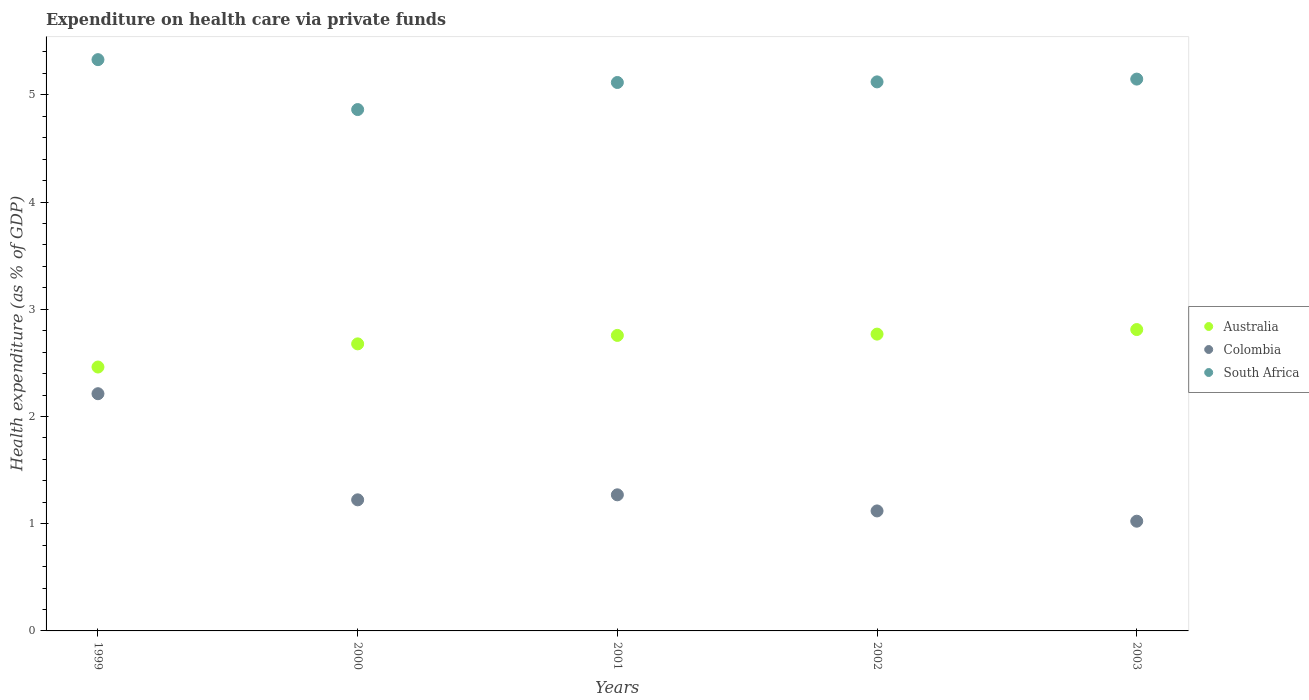What is the expenditure made on health care in Colombia in 2002?
Provide a succinct answer. 1.12. Across all years, what is the maximum expenditure made on health care in Australia?
Give a very brief answer. 2.81. Across all years, what is the minimum expenditure made on health care in Colombia?
Make the answer very short. 1.02. In which year was the expenditure made on health care in Australia maximum?
Make the answer very short. 2003. What is the total expenditure made on health care in Australia in the graph?
Ensure brevity in your answer.  13.47. What is the difference between the expenditure made on health care in Colombia in 2001 and that in 2003?
Offer a terse response. 0.25. What is the difference between the expenditure made on health care in Australia in 2002 and the expenditure made on health care in Colombia in 1999?
Make the answer very short. 0.56. What is the average expenditure made on health care in South Africa per year?
Offer a terse response. 5.12. In the year 2003, what is the difference between the expenditure made on health care in Colombia and expenditure made on health care in Australia?
Your response must be concise. -1.79. In how many years, is the expenditure made on health care in Colombia greater than 2.4 %?
Your answer should be compact. 0. What is the ratio of the expenditure made on health care in Australia in 2002 to that in 2003?
Provide a short and direct response. 0.98. Is the difference between the expenditure made on health care in Colombia in 2001 and 2003 greater than the difference between the expenditure made on health care in Australia in 2001 and 2003?
Keep it short and to the point. Yes. What is the difference between the highest and the second highest expenditure made on health care in Australia?
Provide a succinct answer. 0.04. What is the difference between the highest and the lowest expenditure made on health care in South Africa?
Your response must be concise. 0.47. Is the expenditure made on health care in Australia strictly greater than the expenditure made on health care in South Africa over the years?
Your answer should be very brief. No. Is the expenditure made on health care in Australia strictly less than the expenditure made on health care in South Africa over the years?
Your answer should be compact. Yes. How many years are there in the graph?
Make the answer very short. 5. Are the values on the major ticks of Y-axis written in scientific E-notation?
Make the answer very short. No. Does the graph contain any zero values?
Offer a very short reply. No. How many legend labels are there?
Make the answer very short. 3. What is the title of the graph?
Make the answer very short. Expenditure on health care via private funds. What is the label or title of the Y-axis?
Offer a terse response. Health expenditure (as % of GDP). What is the Health expenditure (as % of GDP) in Australia in 1999?
Ensure brevity in your answer.  2.46. What is the Health expenditure (as % of GDP) in Colombia in 1999?
Your answer should be very brief. 2.21. What is the Health expenditure (as % of GDP) of South Africa in 1999?
Keep it short and to the point. 5.33. What is the Health expenditure (as % of GDP) in Australia in 2000?
Give a very brief answer. 2.68. What is the Health expenditure (as % of GDP) in Colombia in 2000?
Ensure brevity in your answer.  1.22. What is the Health expenditure (as % of GDP) of South Africa in 2000?
Offer a very short reply. 4.86. What is the Health expenditure (as % of GDP) in Australia in 2001?
Provide a succinct answer. 2.76. What is the Health expenditure (as % of GDP) of Colombia in 2001?
Give a very brief answer. 1.27. What is the Health expenditure (as % of GDP) in South Africa in 2001?
Offer a terse response. 5.12. What is the Health expenditure (as % of GDP) in Australia in 2002?
Your answer should be compact. 2.77. What is the Health expenditure (as % of GDP) in Colombia in 2002?
Offer a terse response. 1.12. What is the Health expenditure (as % of GDP) in South Africa in 2002?
Your response must be concise. 5.12. What is the Health expenditure (as % of GDP) in Australia in 2003?
Your answer should be compact. 2.81. What is the Health expenditure (as % of GDP) of Colombia in 2003?
Your answer should be compact. 1.02. What is the Health expenditure (as % of GDP) in South Africa in 2003?
Your response must be concise. 5.15. Across all years, what is the maximum Health expenditure (as % of GDP) of Australia?
Offer a terse response. 2.81. Across all years, what is the maximum Health expenditure (as % of GDP) in Colombia?
Your response must be concise. 2.21. Across all years, what is the maximum Health expenditure (as % of GDP) in South Africa?
Give a very brief answer. 5.33. Across all years, what is the minimum Health expenditure (as % of GDP) of Australia?
Provide a succinct answer. 2.46. Across all years, what is the minimum Health expenditure (as % of GDP) in Colombia?
Your answer should be very brief. 1.02. Across all years, what is the minimum Health expenditure (as % of GDP) of South Africa?
Offer a very short reply. 4.86. What is the total Health expenditure (as % of GDP) of Australia in the graph?
Ensure brevity in your answer.  13.47. What is the total Health expenditure (as % of GDP) of Colombia in the graph?
Provide a succinct answer. 6.85. What is the total Health expenditure (as % of GDP) in South Africa in the graph?
Your response must be concise. 25.58. What is the difference between the Health expenditure (as % of GDP) in Australia in 1999 and that in 2000?
Your answer should be compact. -0.22. What is the difference between the Health expenditure (as % of GDP) of Colombia in 1999 and that in 2000?
Ensure brevity in your answer.  0.99. What is the difference between the Health expenditure (as % of GDP) in South Africa in 1999 and that in 2000?
Give a very brief answer. 0.47. What is the difference between the Health expenditure (as % of GDP) in Australia in 1999 and that in 2001?
Keep it short and to the point. -0.29. What is the difference between the Health expenditure (as % of GDP) in Colombia in 1999 and that in 2001?
Your response must be concise. 0.94. What is the difference between the Health expenditure (as % of GDP) in South Africa in 1999 and that in 2001?
Provide a succinct answer. 0.21. What is the difference between the Health expenditure (as % of GDP) in Australia in 1999 and that in 2002?
Offer a very short reply. -0.31. What is the difference between the Health expenditure (as % of GDP) in Colombia in 1999 and that in 2002?
Ensure brevity in your answer.  1.09. What is the difference between the Health expenditure (as % of GDP) in South Africa in 1999 and that in 2002?
Make the answer very short. 0.21. What is the difference between the Health expenditure (as % of GDP) in Australia in 1999 and that in 2003?
Ensure brevity in your answer.  -0.35. What is the difference between the Health expenditure (as % of GDP) in Colombia in 1999 and that in 2003?
Provide a short and direct response. 1.19. What is the difference between the Health expenditure (as % of GDP) of South Africa in 1999 and that in 2003?
Offer a terse response. 0.18. What is the difference between the Health expenditure (as % of GDP) of Australia in 2000 and that in 2001?
Make the answer very short. -0.08. What is the difference between the Health expenditure (as % of GDP) in Colombia in 2000 and that in 2001?
Make the answer very short. -0.05. What is the difference between the Health expenditure (as % of GDP) in South Africa in 2000 and that in 2001?
Make the answer very short. -0.25. What is the difference between the Health expenditure (as % of GDP) in Australia in 2000 and that in 2002?
Keep it short and to the point. -0.09. What is the difference between the Health expenditure (as % of GDP) in Colombia in 2000 and that in 2002?
Provide a short and direct response. 0.1. What is the difference between the Health expenditure (as % of GDP) of South Africa in 2000 and that in 2002?
Make the answer very short. -0.26. What is the difference between the Health expenditure (as % of GDP) in Australia in 2000 and that in 2003?
Provide a short and direct response. -0.13. What is the difference between the Health expenditure (as % of GDP) of Colombia in 2000 and that in 2003?
Your answer should be compact. 0.2. What is the difference between the Health expenditure (as % of GDP) in South Africa in 2000 and that in 2003?
Ensure brevity in your answer.  -0.28. What is the difference between the Health expenditure (as % of GDP) in Australia in 2001 and that in 2002?
Keep it short and to the point. -0.01. What is the difference between the Health expenditure (as % of GDP) in Colombia in 2001 and that in 2002?
Offer a very short reply. 0.15. What is the difference between the Health expenditure (as % of GDP) in South Africa in 2001 and that in 2002?
Offer a terse response. -0.01. What is the difference between the Health expenditure (as % of GDP) in Australia in 2001 and that in 2003?
Provide a short and direct response. -0.05. What is the difference between the Health expenditure (as % of GDP) in Colombia in 2001 and that in 2003?
Your answer should be very brief. 0.25. What is the difference between the Health expenditure (as % of GDP) in South Africa in 2001 and that in 2003?
Your response must be concise. -0.03. What is the difference between the Health expenditure (as % of GDP) in Australia in 2002 and that in 2003?
Offer a very short reply. -0.04. What is the difference between the Health expenditure (as % of GDP) of Colombia in 2002 and that in 2003?
Offer a terse response. 0.1. What is the difference between the Health expenditure (as % of GDP) of South Africa in 2002 and that in 2003?
Give a very brief answer. -0.03. What is the difference between the Health expenditure (as % of GDP) of Australia in 1999 and the Health expenditure (as % of GDP) of Colombia in 2000?
Your answer should be compact. 1.24. What is the difference between the Health expenditure (as % of GDP) of Australia in 1999 and the Health expenditure (as % of GDP) of South Africa in 2000?
Offer a terse response. -2.4. What is the difference between the Health expenditure (as % of GDP) of Colombia in 1999 and the Health expenditure (as % of GDP) of South Africa in 2000?
Make the answer very short. -2.65. What is the difference between the Health expenditure (as % of GDP) in Australia in 1999 and the Health expenditure (as % of GDP) in Colombia in 2001?
Provide a short and direct response. 1.19. What is the difference between the Health expenditure (as % of GDP) in Australia in 1999 and the Health expenditure (as % of GDP) in South Africa in 2001?
Your answer should be compact. -2.65. What is the difference between the Health expenditure (as % of GDP) of Colombia in 1999 and the Health expenditure (as % of GDP) of South Africa in 2001?
Offer a very short reply. -2.9. What is the difference between the Health expenditure (as % of GDP) of Australia in 1999 and the Health expenditure (as % of GDP) of Colombia in 2002?
Your answer should be compact. 1.34. What is the difference between the Health expenditure (as % of GDP) in Australia in 1999 and the Health expenditure (as % of GDP) in South Africa in 2002?
Make the answer very short. -2.66. What is the difference between the Health expenditure (as % of GDP) of Colombia in 1999 and the Health expenditure (as % of GDP) of South Africa in 2002?
Give a very brief answer. -2.91. What is the difference between the Health expenditure (as % of GDP) of Australia in 1999 and the Health expenditure (as % of GDP) of Colombia in 2003?
Make the answer very short. 1.44. What is the difference between the Health expenditure (as % of GDP) in Australia in 1999 and the Health expenditure (as % of GDP) in South Africa in 2003?
Give a very brief answer. -2.69. What is the difference between the Health expenditure (as % of GDP) in Colombia in 1999 and the Health expenditure (as % of GDP) in South Africa in 2003?
Your answer should be compact. -2.93. What is the difference between the Health expenditure (as % of GDP) in Australia in 2000 and the Health expenditure (as % of GDP) in Colombia in 2001?
Give a very brief answer. 1.41. What is the difference between the Health expenditure (as % of GDP) of Australia in 2000 and the Health expenditure (as % of GDP) of South Africa in 2001?
Ensure brevity in your answer.  -2.44. What is the difference between the Health expenditure (as % of GDP) of Colombia in 2000 and the Health expenditure (as % of GDP) of South Africa in 2001?
Give a very brief answer. -3.89. What is the difference between the Health expenditure (as % of GDP) in Australia in 2000 and the Health expenditure (as % of GDP) in Colombia in 2002?
Provide a succinct answer. 1.56. What is the difference between the Health expenditure (as % of GDP) of Australia in 2000 and the Health expenditure (as % of GDP) of South Africa in 2002?
Make the answer very short. -2.44. What is the difference between the Health expenditure (as % of GDP) of Colombia in 2000 and the Health expenditure (as % of GDP) of South Africa in 2002?
Your response must be concise. -3.9. What is the difference between the Health expenditure (as % of GDP) of Australia in 2000 and the Health expenditure (as % of GDP) of Colombia in 2003?
Keep it short and to the point. 1.65. What is the difference between the Health expenditure (as % of GDP) of Australia in 2000 and the Health expenditure (as % of GDP) of South Africa in 2003?
Your answer should be very brief. -2.47. What is the difference between the Health expenditure (as % of GDP) in Colombia in 2000 and the Health expenditure (as % of GDP) in South Africa in 2003?
Your answer should be compact. -3.92. What is the difference between the Health expenditure (as % of GDP) of Australia in 2001 and the Health expenditure (as % of GDP) of Colombia in 2002?
Your response must be concise. 1.64. What is the difference between the Health expenditure (as % of GDP) in Australia in 2001 and the Health expenditure (as % of GDP) in South Africa in 2002?
Offer a terse response. -2.36. What is the difference between the Health expenditure (as % of GDP) in Colombia in 2001 and the Health expenditure (as % of GDP) in South Africa in 2002?
Ensure brevity in your answer.  -3.85. What is the difference between the Health expenditure (as % of GDP) of Australia in 2001 and the Health expenditure (as % of GDP) of Colombia in 2003?
Offer a terse response. 1.73. What is the difference between the Health expenditure (as % of GDP) in Australia in 2001 and the Health expenditure (as % of GDP) in South Africa in 2003?
Ensure brevity in your answer.  -2.39. What is the difference between the Health expenditure (as % of GDP) of Colombia in 2001 and the Health expenditure (as % of GDP) of South Africa in 2003?
Offer a very short reply. -3.88. What is the difference between the Health expenditure (as % of GDP) of Australia in 2002 and the Health expenditure (as % of GDP) of Colombia in 2003?
Ensure brevity in your answer.  1.75. What is the difference between the Health expenditure (as % of GDP) in Australia in 2002 and the Health expenditure (as % of GDP) in South Africa in 2003?
Offer a very short reply. -2.38. What is the difference between the Health expenditure (as % of GDP) in Colombia in 2002 and the Health expenditure (as % of GDP) in South Africa in 2003?
Your response must be concise. -4.03. What is the average Health expenditure (as % of GDP) in Australia per year?
Your answer should be very brief. 2.69. What is the average Health expenditure (as % of GDP) in Colombia per year?
Offer a very short reply. 1.37. What is the average Health expenditure (as % of GDP) of South Africa per year?
Ensure brevity in your answer.  5.12. In the year 1999, what is the difference between the Health expenditure (as % of GDP) of Australia and Health expenditure (as % of GDP) of Colombia?
Offer a terse response. 0.25. In the year 1999, what is the difference between the Health expenditure (as % of GDP) of Australia and Health expenditure (as % of GDP) of South Africa?
Provide a succinct answer. -2.87. In the year 1999, what is the difference between the Health expenditure (as % of GDP) of Colombia and Health expenditure (as % of GDP) of South Africa?
Provide a short and direct response. -3.12. In the year 2000, what is the difference between the Health expenditure (as % of GDP) of Australia and Health expenditure (as % of GDP) of Colombia?
Provide a short and direct response. 1.45. In the year 2000, what is the difference between the Health expenditure (as % of GDP) in Australia and Health expenditure (as % of GDP) in South Africa?
Offer a very short reply. -2.19. In the year 2000, what is the difference between the Health expenditure (as % of GDP) in Colombia and Health expenditure (as % of GDP) in South Africa?
Provide a succinct answer. -3.64. In the year 2001, what is the difference between the Health expenditure (as % of GDP) of Australia and Health expenditure (as % of GDP) of Colombia?
Ensure brevity in your answer.  1.49. In the year 2001, what is the difference between the Health expenditure (as % of GDP) in Australia and Health expenditure (as % of GDP) in South Africa?
Ensure brevity in your answer.  -2.36. In the year 2001, what is the difference between the Health expenditure (as % of GDP) of Colombia and Health expenditure (as % of GDP) of South Africa?
Offer a terse response. -3.85. In the year 2002, what is the difference between the Health expenditure (as % of GDP) of Australia and Health expenditure (as % of GDP) of Colombia?
Give a very brief answer. 1.65. In the year 2002, what is the difference between the Health expenditure (as % of GDP) in Australia and Health expenditure (as % of GDP) in South Africa?
Provide a short and direct response. -2.35. In the year 2002, what is the difference between the Health expenditure (as % of GDP) of Colombia and Health expenditure (as % of GDP) of South Africa?
Your response must be concise. -4. In the year 2003, what is the difference between the Health expenditure (as % of GDP) of Australia and Health expenditure (as % of GDP) of Colombia?
Keep it short and to the point. 1.79. In the year 2003, what is the difference between the Health expenditure (as % of GDP) in Australia and Health expenditure (as % of GDP) in South Africa?
Your answer should be compact. -2.34. In the year 2003, what is the difference between the Health expenditure (as % of GDP) in Colombia and Health expenditure (as % of GDP) in South Africa?
Your answer should be compact. -4.12. What is the ratio of the Health expenditure (as % of GDP) in Australia in 1999 to that in 2000?
Provide a short and direct response. 0.92. What is the ratio of the Health expenditure (as % of GDP) in Colombia in 1999 to that in 2000?
Offer a terse response. 1.81. What is the ratio of the Health expenditure (as % of GDP) in South Africa in 1999 to that in 2000?
Make the answer very short. 1.1. What is the ratio of the Health expenditure (as % of GDP) in Australia in 1999 to that in 2001?
Offer a very short reply. 0.89. What is the ratio of the Health expenditure (as % of GDP) in Colombia in 1999 to that in 2001?
Offer a very short reply. 1.74. What is the ratio of the Health expenditure (as % of GDP) of South Africa in 1999 to that in 2001?
Provide a succinct answer. 1.04. What is the ratio of the Health expenditure (as % of GDP) of Australia in 1999 to that in 2002?
Offer a terse response. 0.89. What is the ratio of the Health expenditure (as % of GDP) in Colombia in 1999 to that in 2002?
Give a very brief answer. 1.98. What is the ratio of the Health expenditure (as % of GDP) of South Africa in 1999 to that in 2002?
Keep it short and to the point. 1.04. What is the ratio of the Health expenditure (as % of GDP) in Australia in 1999 to that in 2003?
Provide a short and direct response. 0.88. What is the ratio of the Health expenditure (as % of GDP) in Colombia in 1999 to that in 2003?
Offer a very short reply. 2.16. What is the ratio of the Health expenditure (as % of GDP) of South Africa in 1999 to that in 2003?
Give a very brief answer. 1.04. What is the ratio of the Health expenditure (as % of GDP) in Australia in 2000 to that in 2001?
Your response must be concise. 0.97. What is the ratio of the Health expenditure (as % of GDP) of Colombia in 2000 to that in 2001?
Make the answer very short. 0.96. What is the ratio of the Health expenditure (as % of GDP) in South Africa in 2000 to that in 2001?
Offer a terse response. 0.95. What is the ratio of the Health expenditure (as % of GDP) in Australia in 2000 to that in 2002?
Give a very brief answer. 0.97. What is the ratio of the Health expenditure (as % of GDP) in Colombia in 2000 to that in 2002?
Give a very brief answer. 1.09. What is the ratio of the Health expenditure (as % of GDP) in South Africa in 2000 to that in 2002?
Your answer should be compact. 0.95. What is the ratio of the Health expenditure (as % of GDP) of Australia in 2000 to that in 2003?
Offer a terse response. 0.95. What is the ratio of the Health expenditure (as % of GDP) of Colombia in 2000 to that in 2003?
Keep it short and to the point. 1.19. What is the ratio of the Health expenditure (as % of GDP) of South Africa in 2000 to that in 2003?
Give a very brief answer. 0.94. What is the ratio of the Health expenditure (as % of GDP) of Australia in 2001 to that in 2002?
Make the answer very short. 1. What is the ratio of the Health expenditure (as % of GDP) of Colombia in 2001 to that in 2002?
Your answer should be compact. 1.13. What is the ratio of the Health expenditure (as % of GDP) of Australia in 2001 to that in 2003?
Make the answer very short. 0.98. What is the ratio of the Health expenditure (as % of GDP) of Colombia in 2001 to that in 2003?
Provide a short and direct response. 1.24. What is the ratio of the Health expenditure (as % of GDP) of South Africa in 2001 to that in 2003?
Ensure brevity in your answer.  0.99. What is the ratio of the Health expenditure (as % of GDP) in Australia in 2002 to that in 2003?
Ensure brevity in your answer.  0.98. What is the ratio of the Health expenditure (as % of GDP) of Colombia in 2002 to that in 2003?
Provide a succinct answer. 1.09. What is the ratio of the Health expenditure (as % of GDP) in South Africa in 2002 to that in 2003?
Keep it short and to the point. 0.99. What is the difference between the highest and the second highest Health expenditure (as % of GDP) in Australia?
Provide a short and direct response. 0.04. What is the difference between the highest and the second highest Health expenditure (as % of GDP) in Colombia?
Keep it short and to the point. 0.94. What is the difference between the highest and the second highest Health expenditure (as % of GDP) in South Africa?
Your answer should be very brief. 0.18. What is the difference between the highest and the lowest Health expenditure (as % of GDP) in Australia?
Ensure brevity in your answer.  0.35. What is the difference between the highest and the lowest Health expenditure (as % of GDP) in Colombia?
Provide a succinct answer. 1.19. What is the difference between the highest and the lowest Health expenditure (as % of GDP) in South Africa?
Give a very brief answer. 0.47. 